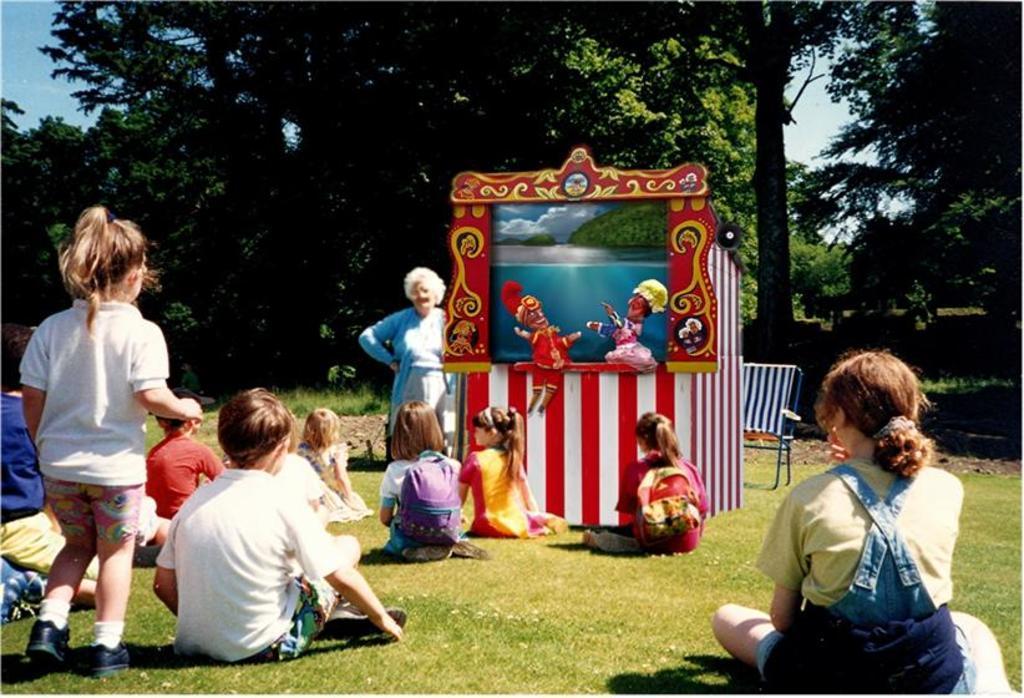Please provide a concise description of this image. In this image I can see at the bottom a group of children are sitting on the ground. On the left side a girl is walking, in the middle it looks like a puppet show and there is a woman standing. At the back side there are trees, at the top there is the sky. 